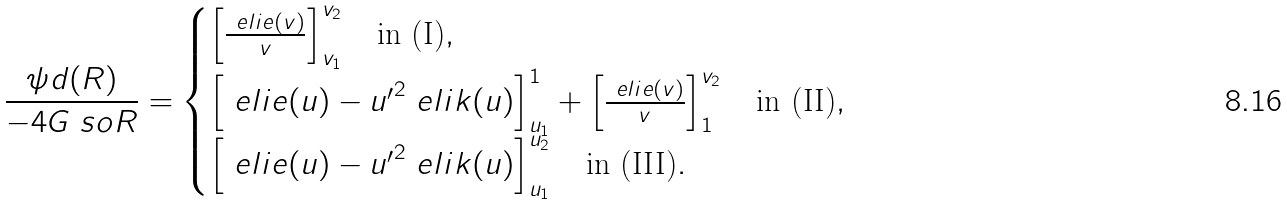Convert formula to latex. <formula><loc_0><loc_0><loc_500><loc_500>\frac { \psi d ( R ) } { - 4 G \ s o R } = \begin{cases} \left [ \frac { \ e l i e ( v ) } { v } \right ] _ { v _ { 1 } } ^ { v _ { 2 } } \quad \text {in (I)} , \\ \left [ \ e l i e ( u ) - { u ^ { \prime } } ^ { 2 } \ e l i k ( u ) \right ] _ { u _ { 1 } } ^ { 1 } + \left [ \frac { \ e l i e ( v ) } { v } \right ] _ { 1 } ^ { v _ { 2 } } \quad \text {in (II)} , \\ \left [ \ e l i e ( u ) - { u ^ { \prime } } ^ { 2 } \ e l i k ( u ) \right ] _ { u _ { 1 } } ^ { u _ { 2 } } \quad \text {in (III)} . \end{cases}</formula> 